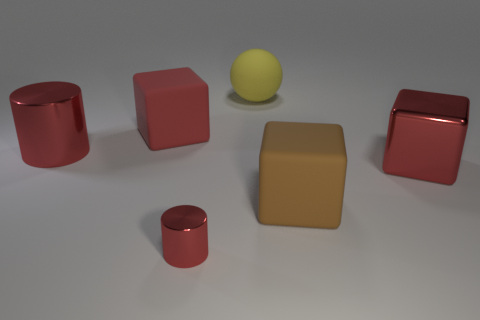Subtract all cyan balls. How many red blocks are left? 2 Subtract all matte blocks. How many blocks are left? 1 Add 1 brown matte blocks. How many objects exist? 7 Subtract all spheres. How many objects are left? 5 Subtract 1 cylinders. How many cylinders are left? 1 Add 2 big brown rubber objects. How many big brown rubber objects exist? 3 Subtract 0 yellow cylinders. How many objects are left? 6 Subtract all purple spheres. Subtract all yellow cubes. How many spheres are left? 1 Subtract all small cyan metal cubes. Subtract all brown objects. How many objects are left? 5 Add 2 yellow rubber things. How many yellow rubber things are left? 3 